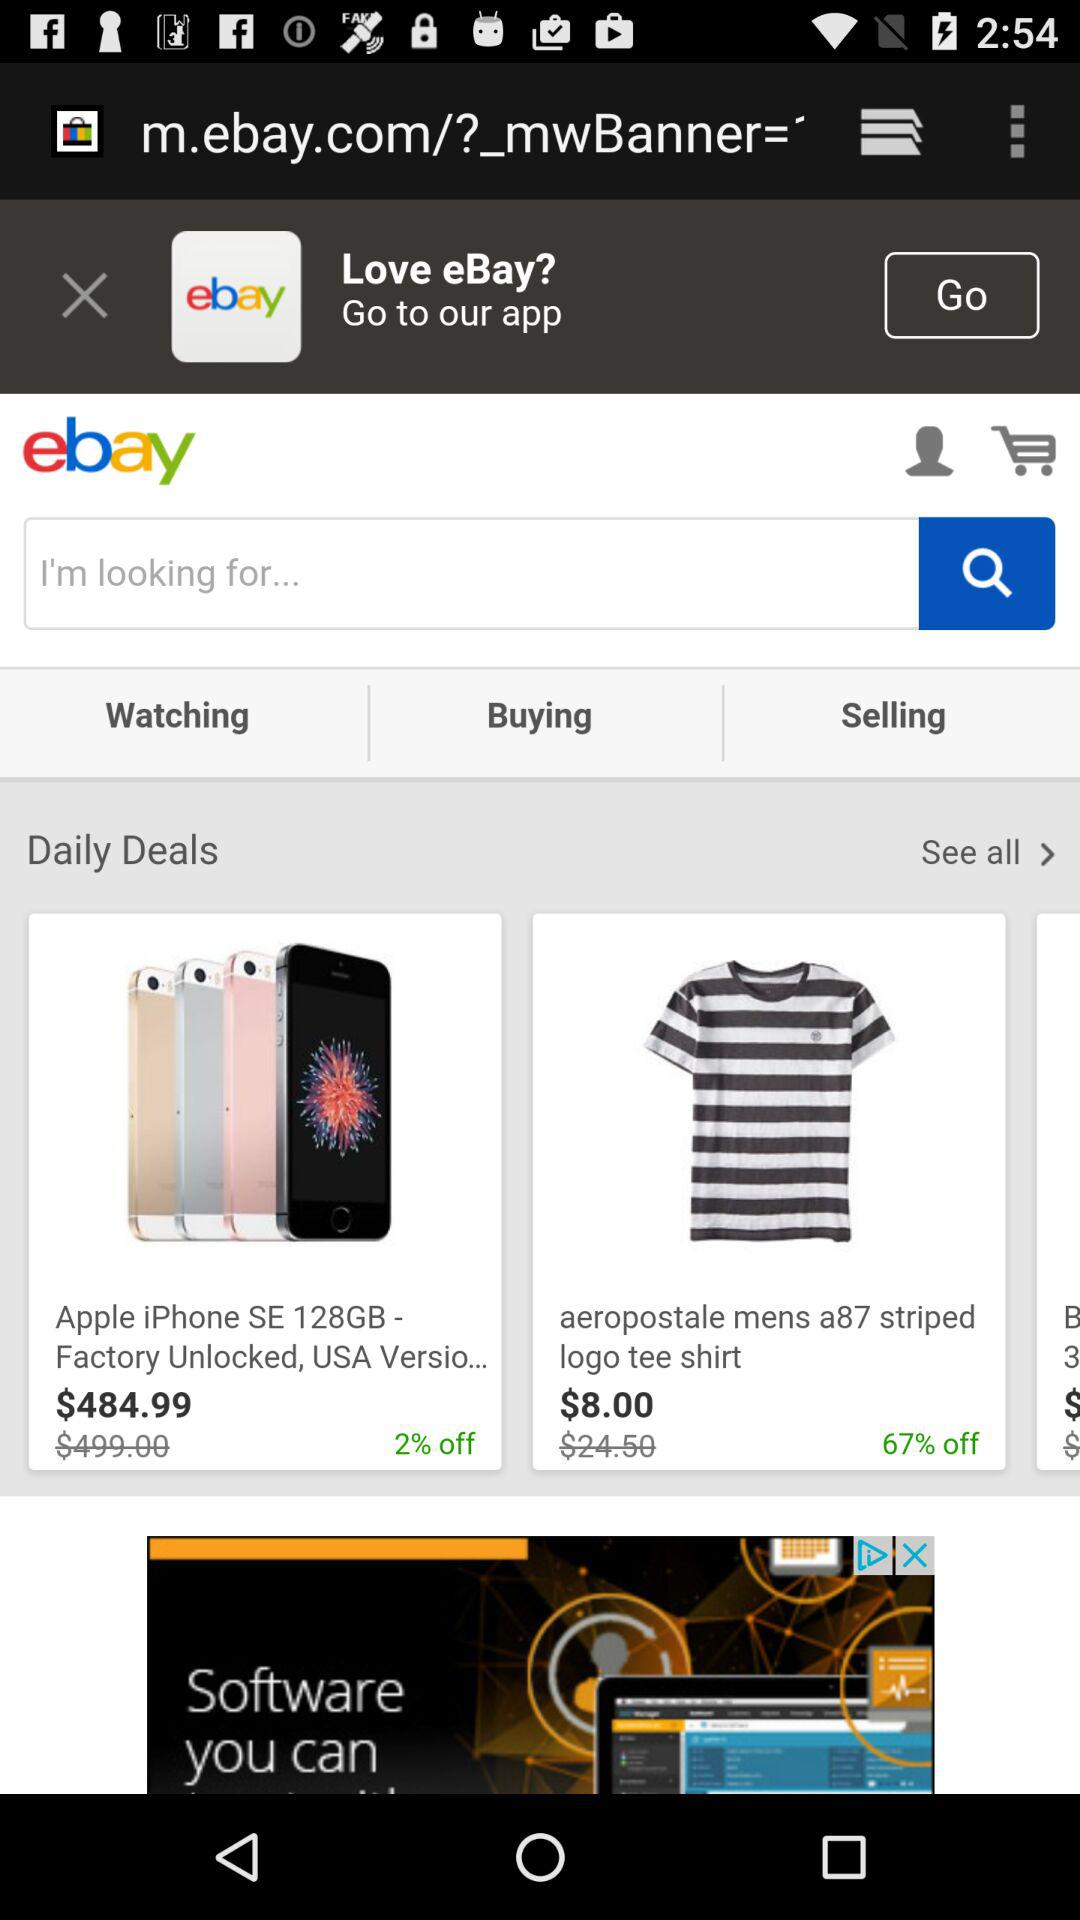What is the discounted price of the phone? The discounted price of the phone is $484.99. 